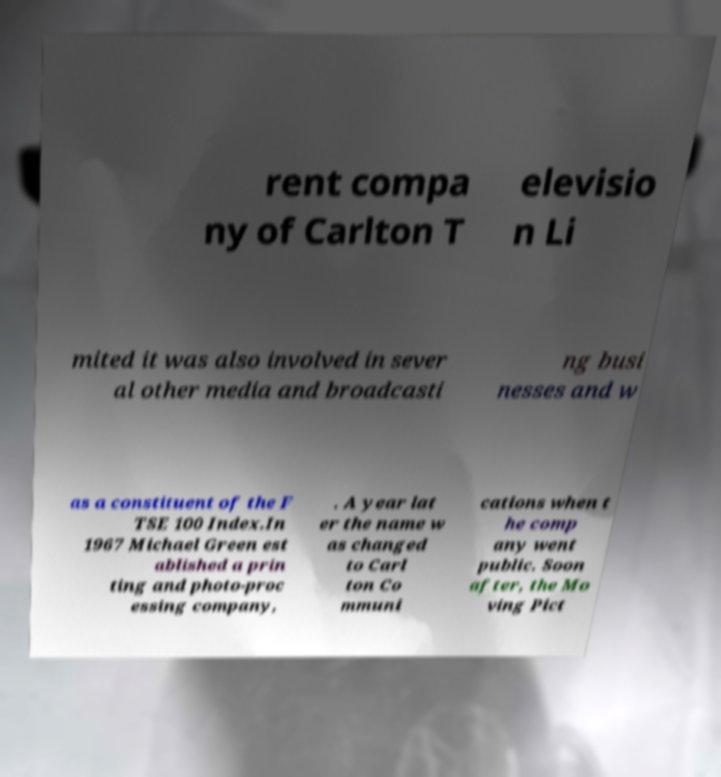There's text embedded in this image that I need extracted. Can you transcribe it verbatim? rent compa ny of Carlton T elevisio n Li mited it was also involved in sever al other media and broadcasti ng busi nesses and w as a constituent of the F TSE 100 Index.In 1967 Michael Green est ablished a prin ting and photo-proc essing company, . A year lat er the name w as changed to Carl ton Co mmuni cations when t he comp any went public. Soon after, the Mo ving Pict 